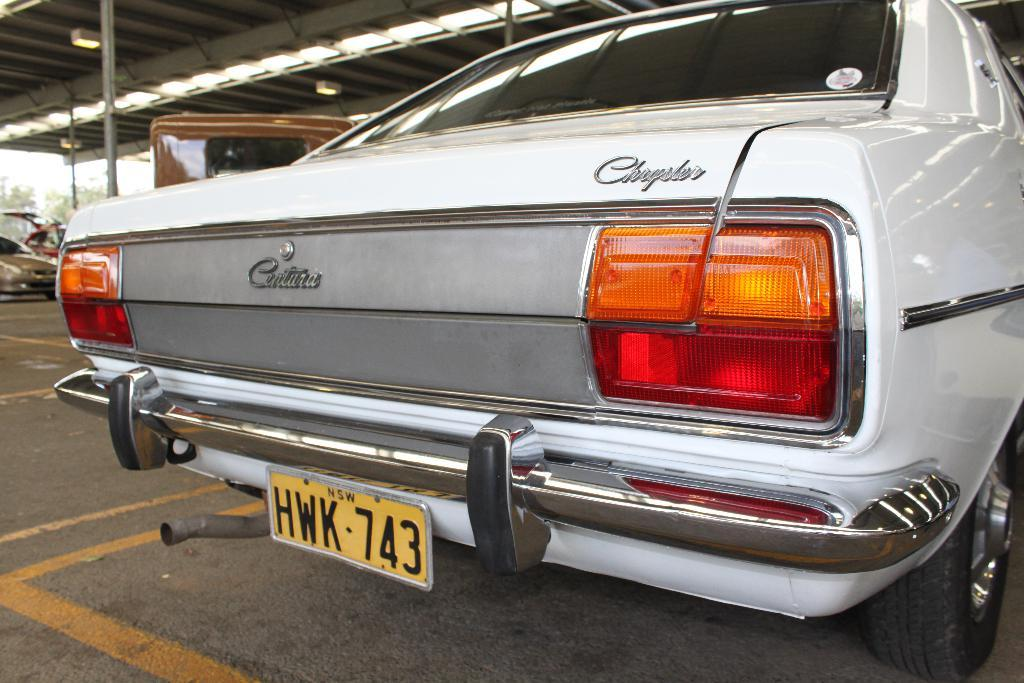What is the main subject of the image? The main subject of the image is a car on the road. Can you describe the location of the other cars in the image? There are many cars under a shed in the image. How many giants are visible in the image? There are no giants present in the image. What type of tree can be seen growing near the shed in the image? There is no tree visible in the image; it only shows cars on the road and under a shed. 